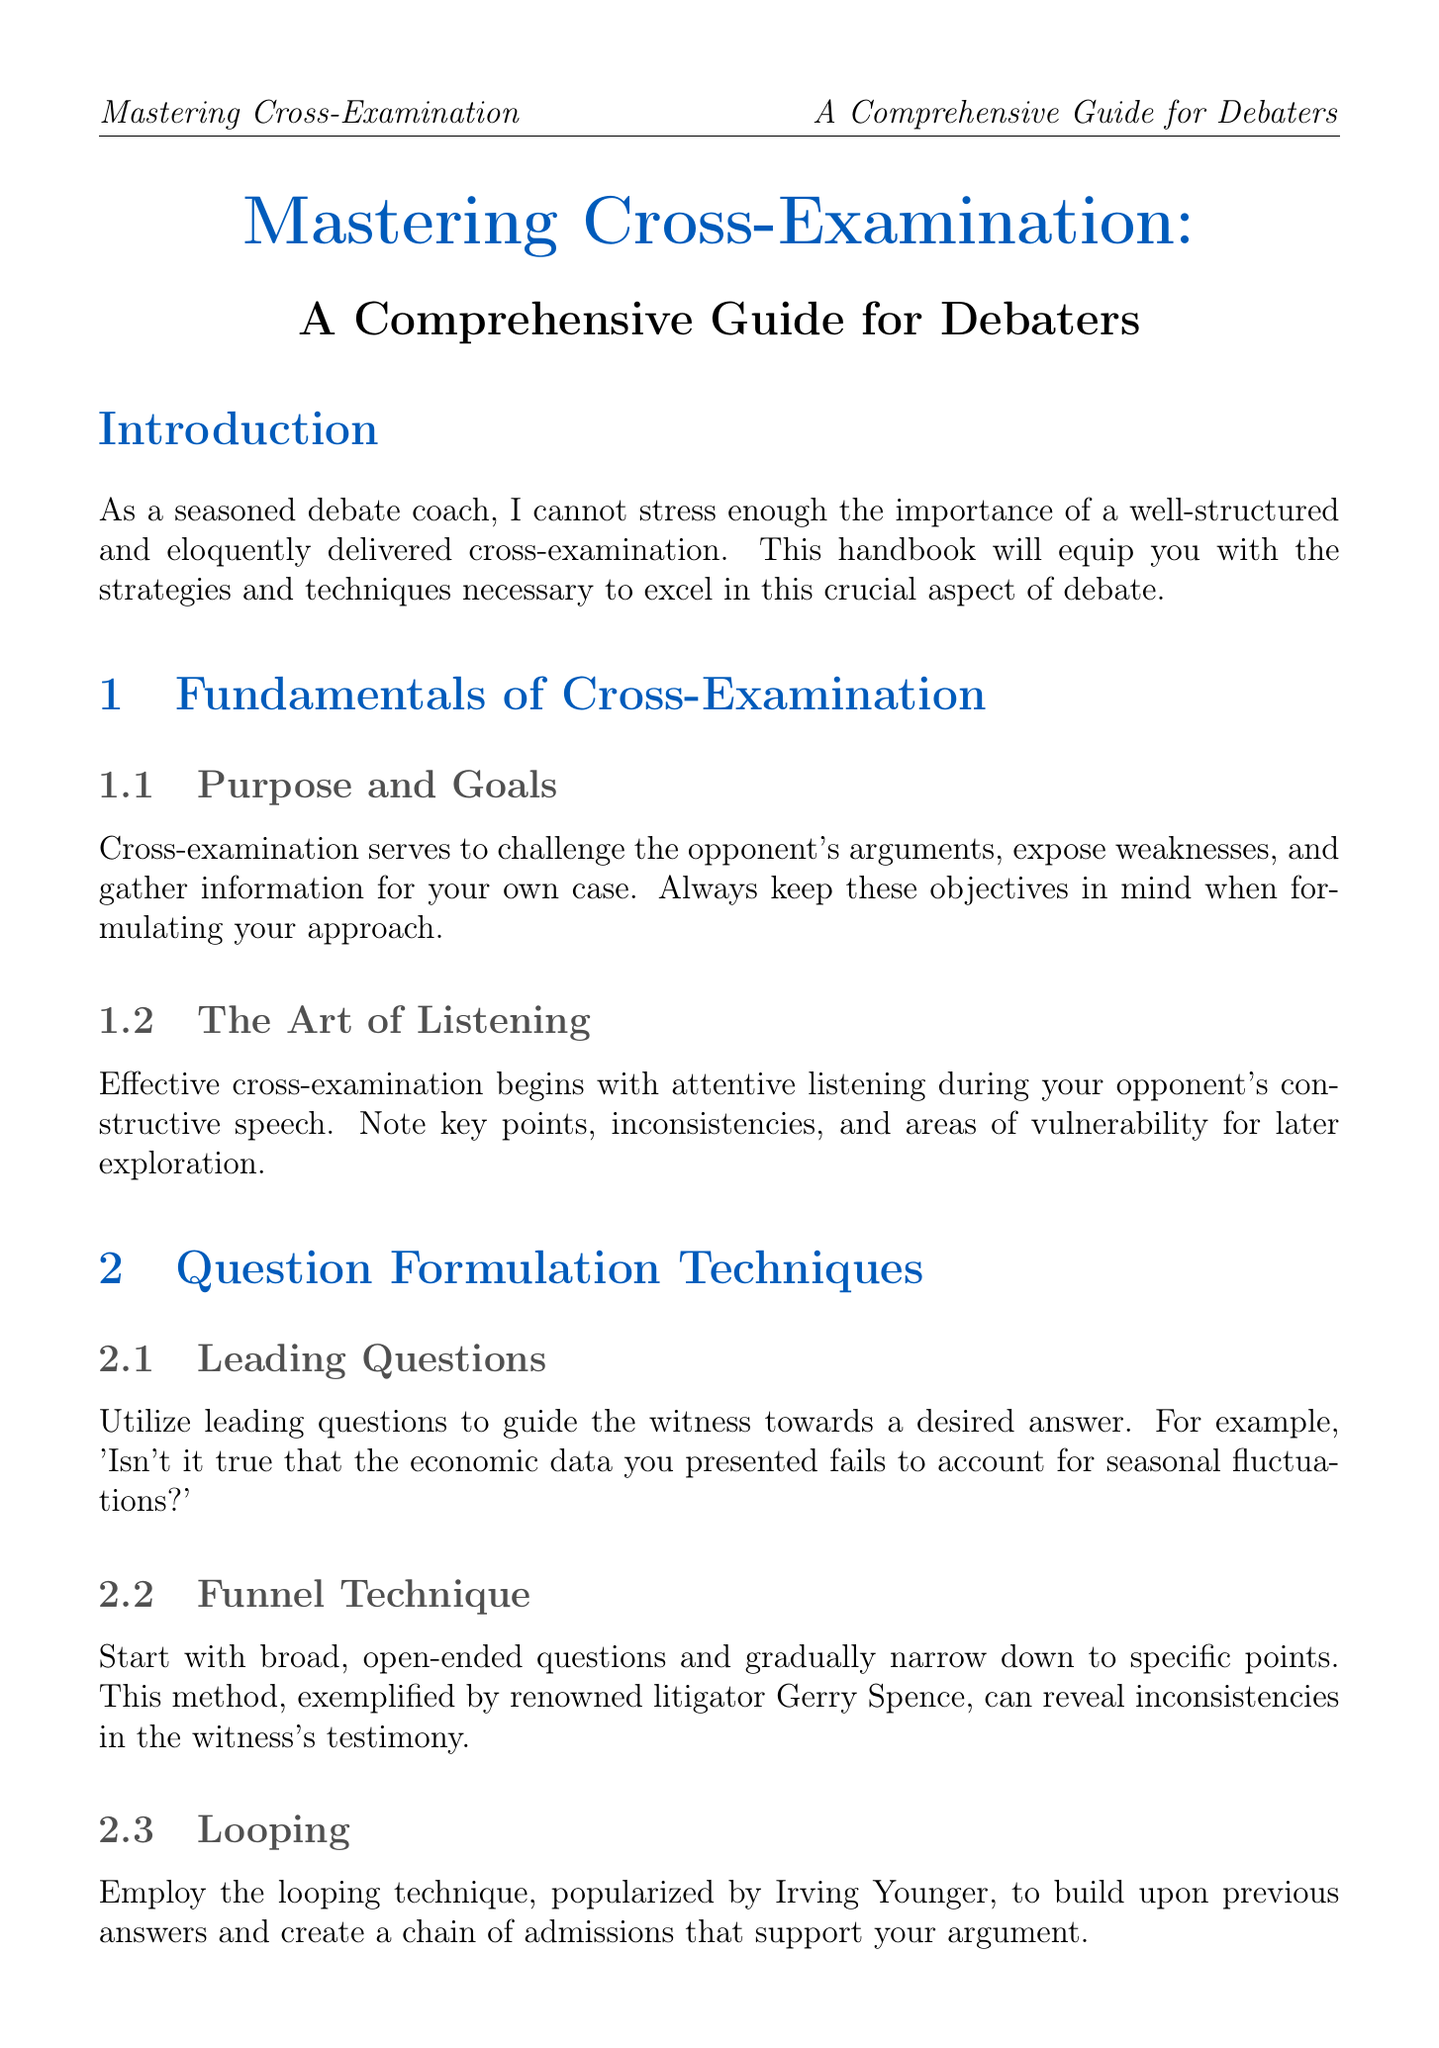What is the title of the handbook? The title is explicitly mentioned at the beginning of the document, indicating its primary focus on cross-examination strategies for debaters.
Answer: Mastering Cross-Examination: A Comprehensive Guide for Debaters What is one purpose of cross-examination? The document specifies that cross-examination serves to challenge the opponent's arguments, among other objectives.
Answer: Challenge the opponent's arguments Who popularized the looping technique? The handbook attributes the looping technique to a well-known figure in cross-examination strategies, providing a clear reference to its origin.
Answer: Irving Younger In what section would you find witness handling strategies? Witness handling strategies are discussed in a distinct section that addresses approaches related to witnesses in cross-examinations.
Answer: Witness Handling Strategies What technique involves starting with broad questions? The document describes a specific technique related to question formulation that involves beginning with broad queries before narrowing down.
Answer: Funnel Technique What is an ethical consideration mentioned in the handbook? The document highlights a specific ethical standard that should be upheld during cross-examination, emphasizing the importance of integrity.
Answer: Avoid badgering witnesses What method should be used to establish a witness's credibility? The handbook outlines the initial step in questioning that involves establishing credentials and biases of the witness to influence their testimony perception.
Answer: Establishing Credibility Which famous trial did F. Lee Bailey handle techniques from? The document mentions a specific trial where techniques for handling hostile witnesses were illustrated, providing historical context.
Answer: O.J. Simpson trial 